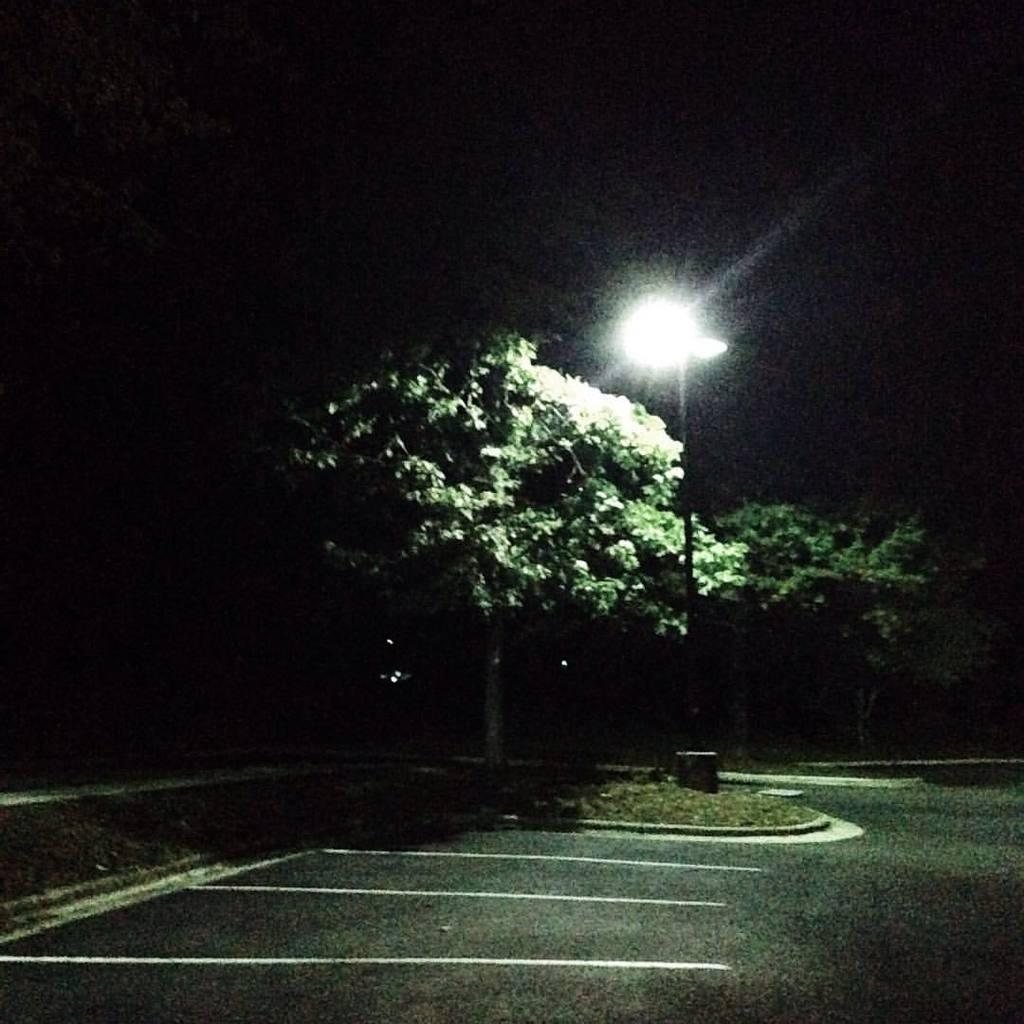What type of surface is visible in the image? There is a road in the image. What type of vegetation can be seen in the image? There is grass and trees in the image. What structure is present in the image? There is a light pole in the image. What is the color of the background in the image? The background of the image is dark. How many dogs are running in a circle in the image? There are no dogs or circles present in the image. What type of chickens can be seen in the image? There are no chickens present in the image. 